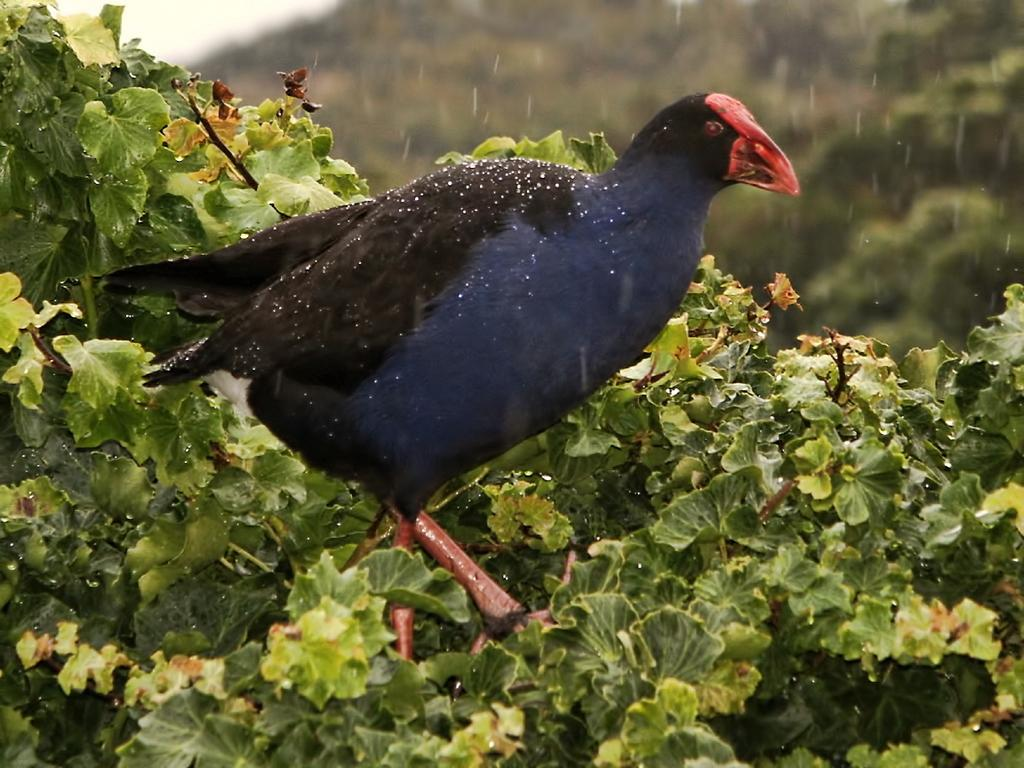What type of animal can be seen in the image? There is a bird in the image. Where is the bird located in the image? The bird is on the plants. What type of meat is being prepared on the river in the image? There is no meat or river present in the image; it features a bird on plants. 